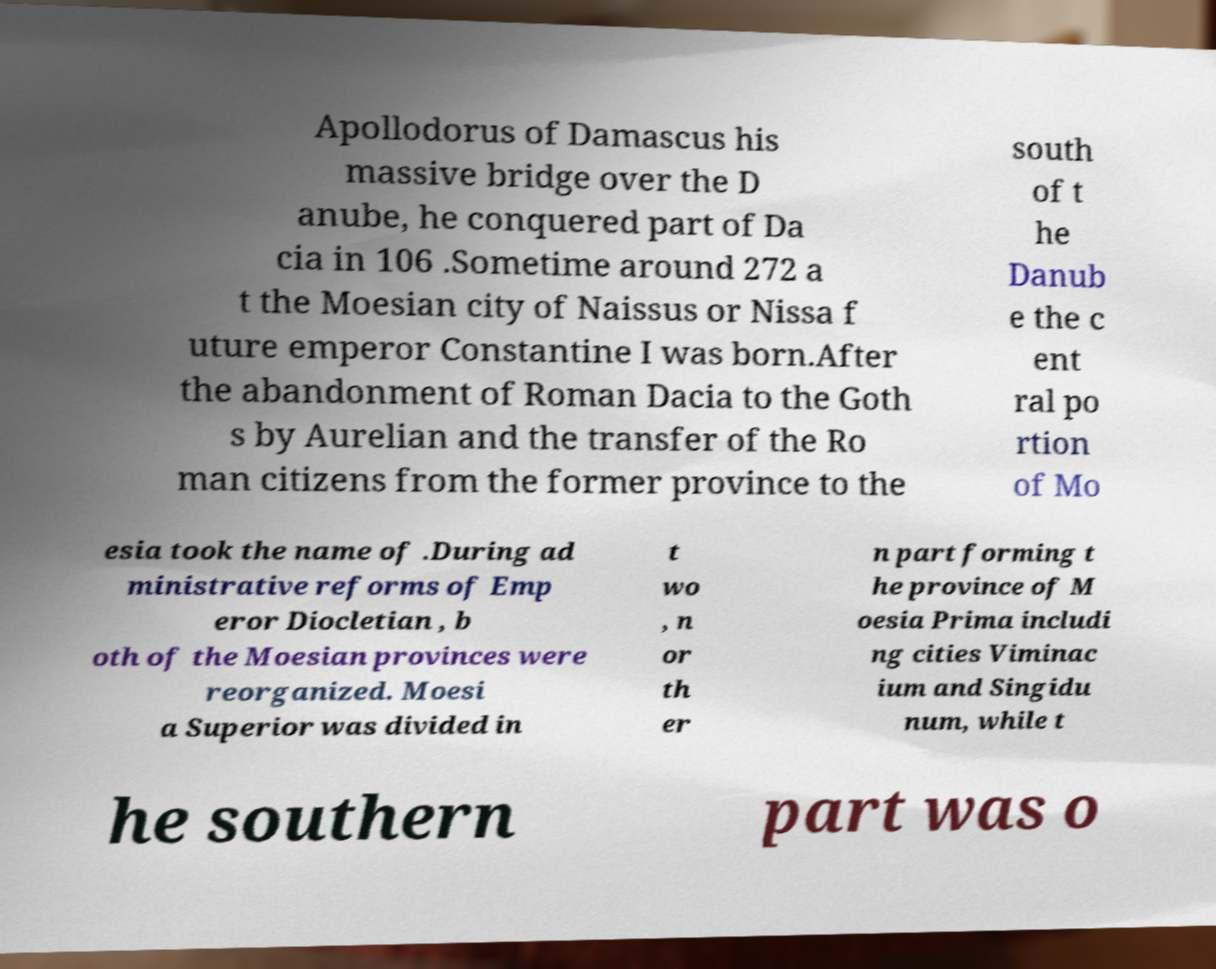Please read and relay the text visible in this image. What does it say? Apollodorus of Damascus his massive bridge over the D anube, he conquered part of Da cia in 106 .Sometime around 272 a t the Moesian city of Naissus or Nissa f uture emperor Constantine I was born.After the abandonment of Roman Dacia to the Goth s by Aurelian and the transfer of the Ro man citizens from the former province to the south of t he Danub e the c ent ral po rtion of Mo esia took the name of .During ad ministrative reforms of Emp eror Diocletian , b oth of the Moesian provinces were reorganized. Moesi a Superior was divided in t wo , n or th er n part forming t he province of M oesia Prima includi ng cities Viminac ium and Singidu num, while t he southern part was o 